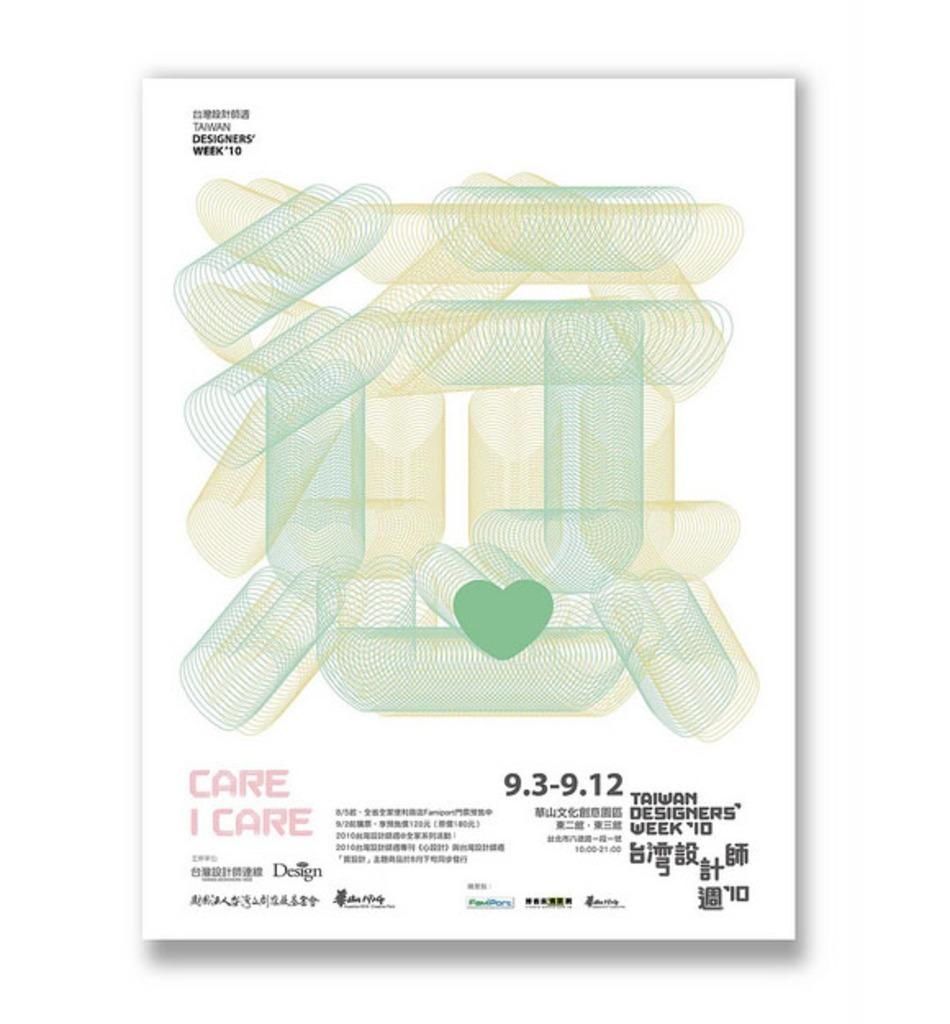What is the main object in the center of the image? There is a white color object in the center of the image. What can be found on the object? The object has text, numbers, and pictures on it. What is the color of the background in the image? The background of the image is white in color. Can you see any cats playing with cream in the image? There are no cats or cream present in the image. Is there an airport visible in the background of the image? There is no airport visible in the image; the background is white. 